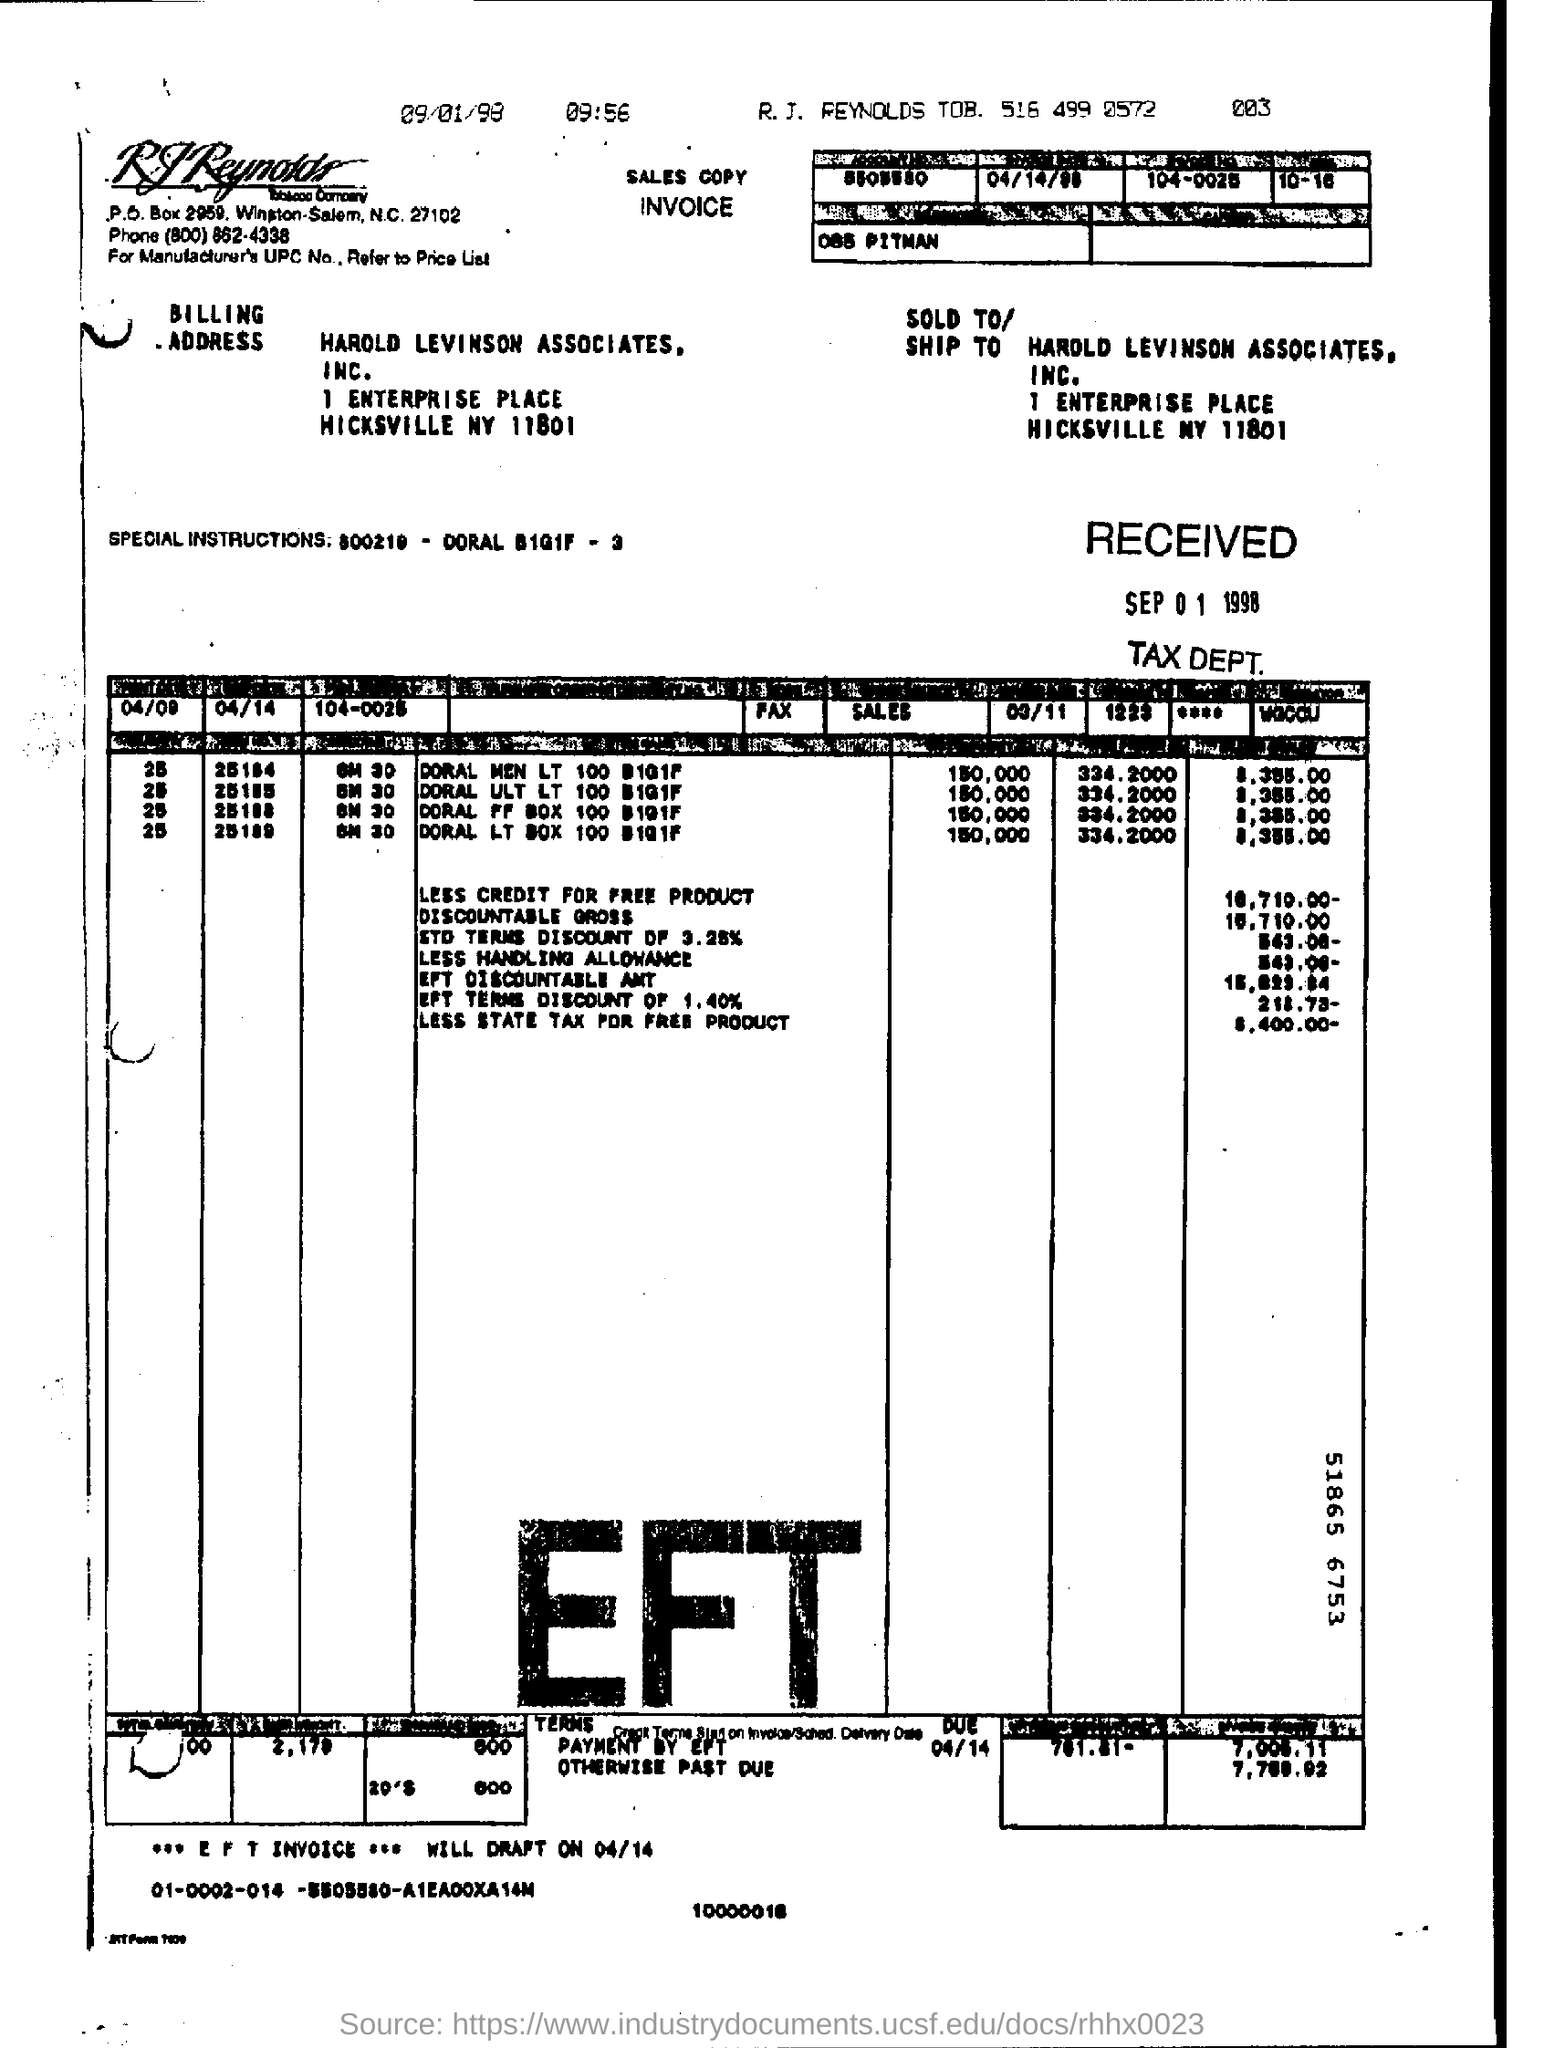What is the zipcode of rj reynolds tobacco company?
Offer a very short reply. 27102. 